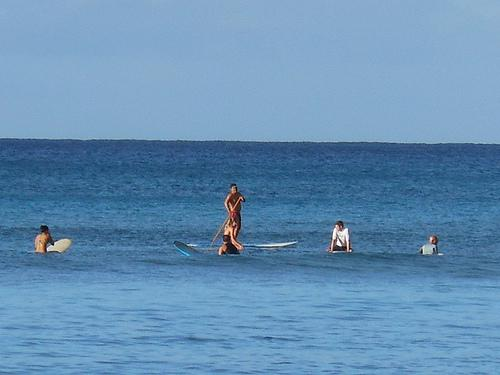Question: why does the man have a pole?
Choices:
A. To pole vault.
B. To help him walk.
C. To build something.
D. To paddle.
Answer with the letter. Answer: D Question: how many clouds are in the sky?
Choices:
A. Sunny.
B. Clear.
C. None.
D. Blue.
Answer with the letter. Answer: C Question: how many surfers are wearing white shirts?
Choices:
A. Two.
B. None.
C. One.
D. Three.
Answer with the letter. Answer: C 